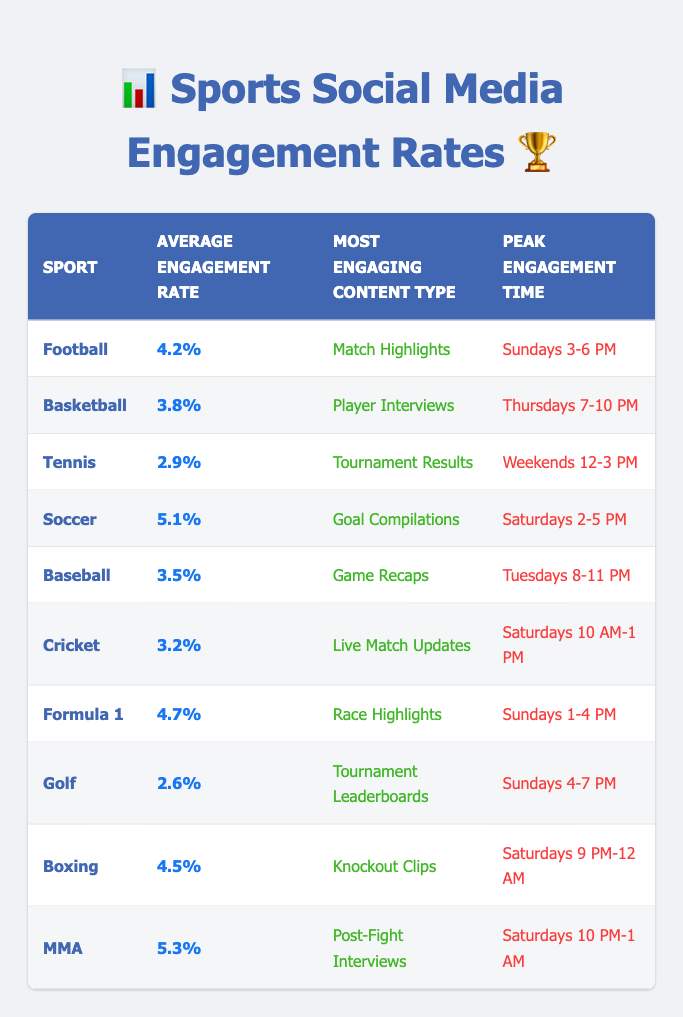What is the average engagement rate for Soccer? The table shows that the average engagement rate for Soccer is 5.1%.
Answer: 5.1% Which sport has the lowest average engagement rate? Looking through the table, Golf has the lowest average engagement rate at 2.6%.
Answer: Golf Is the most engaging content type for Baseball Game Recaps? The table lists the most engaging content type for Baseball as Game Recaps; therefore, the statement is True.
Answer: Yes What is the peak engagement time for MMA? According to the table, the peak engagement time for MMA is Saturdays from 10 PM to 1 AM.
Answer: Saturdays 10 PM-1 AM Which sport(s) have an average engagement rate above 4%? By scanning the engagement rates, Football (4.2%), Soccer (5.1%), Formula 1 (4.7%), Boxing (4.5%), and MMA (5.3%) all have engagement rates above 4%.
Answer: Football, Soccer, Formula 1, Boxing, MMA How does the average engagement rate for Tennis compare to Cricket? The average engagement rate for Tennis is 2.9%, and for Cricket, it's 3.2%. Since 2.9% is less than 3.2%, Tennis has a lower engagement rate compared to Cricket.
Answer: Tennis has a lower engagement rate What percentage points difference is there between the highest and lowest engagement rates in this table? The highest engagement rate is for MMA at 5.3%, and the lowest is Golf at 2.6%. The difference is calculated as 5.3% - 2.6% = 2.7 percentage points.
Answer: 2.7 percentage points What is the most engaging content type for the sport with the second highest engagement rate? The table indicates that MMA has the highest engagement rate (5.3%), and the second highest is Soccer (5.1%). For Soccer, the most engaging content type is Goal Compilations.
Answer: Goal Compilations Which sport experiences peak engagement on Sundays? The table shows that Football, Formula 1, and Golf all have peak engagement times on Sundays. Therefore, the answer comprises these sports.
Answer: Football, Formula 1, Golf 